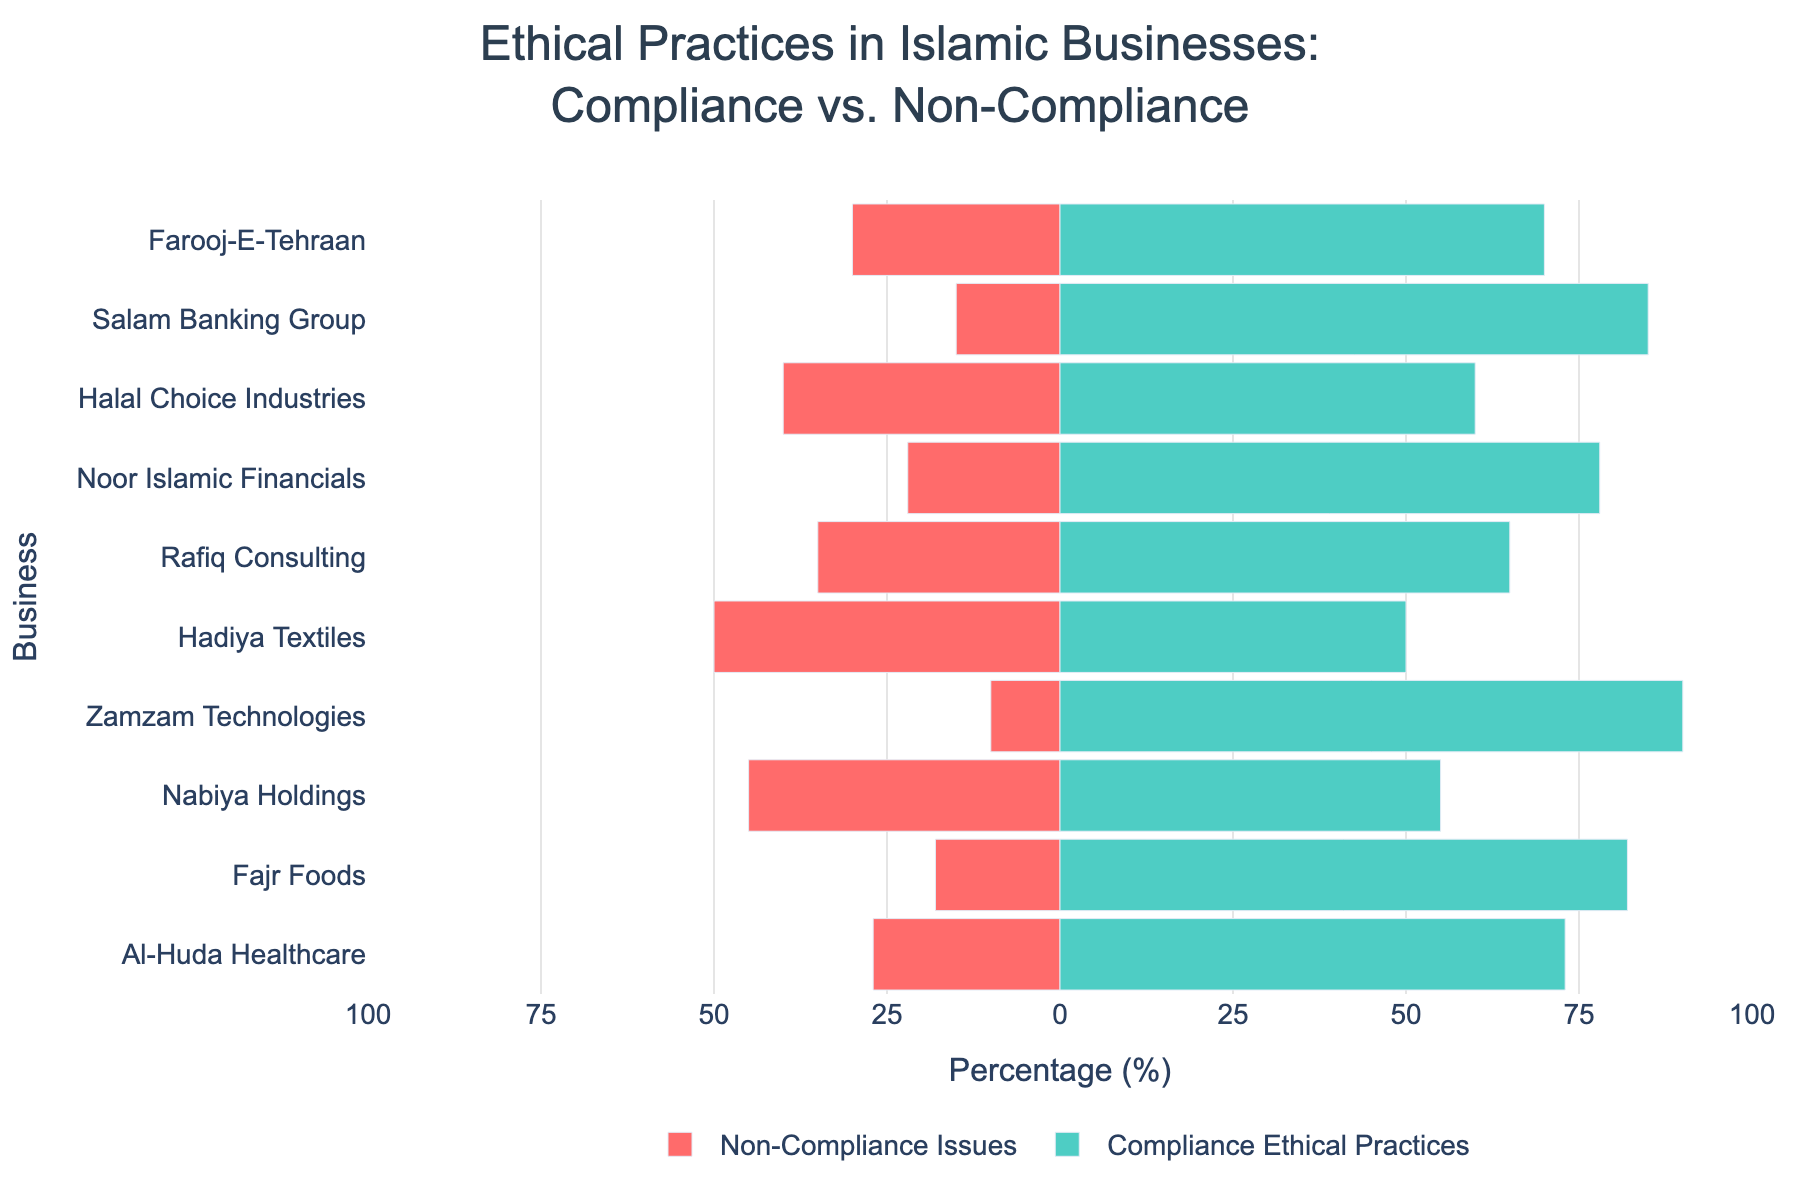Which business has the highest percentage of compliance with ethical practices? To find the business with the highest percentage of compliance, look for the bar with the longest green section. Zamzam Technologies has the highest compliance at 90%.
Answer: Zamzam Technologies Which business has the highest percentage of non-compliance issues? To find the business with the highest percentage of non-compliance issues, look for the bar with the longest red section. Halal Choice Industries has the highest non-compliance at 40%.
Answer: Halal Choice Industries Compare the compliance percentages of Salam Banking Group and Noor Islamic Financials. Which one has higher compliance? Look at the green bars for both Salam Banking Group and Noor Islamic Financials. Salam Banking Group has 85% compliance while Noor Islamic Financials has 78%. So, Salam Banking Group has higher compliance.
Answer: Salam Banking Group What is the combined percentage of compliance for Al-Huda Healthcare and Farooj-E-Tehraan? Al-Huda Healthcare has 73% compliance and Farooj-E-Tehraan has 70% compliance. Adding these together gives 73 + 70 = 143%.
Answer: 143% Among the businesses with more than 30% non-compliance issues, which one has the lowest percentage of non-compliance? First, identify businesses with more than 30% non-compliance: Farooj-E-Tehraan (30%), Halal Choice Industries (40%), Rafiq Consulting (35%), Hadiya Textiles (50%), and Nabiya Holdings (45%). Then, find the lowest percentage: Farooj-E-Tehraan with 30%.
Answer: Farooj-E-Tehraan Which businesses have an equal percentage of compliance and non-compliance? Identify the business where the green and red sections are equal lengths. Hadiya Textiles has 50% compliance and 50% non-compliance, making them equal.
Answer: Hadiya Textiles What is the average compliance percentage across all businesses? Sum the compliance percentages and divide by the number of businesses. (70 + 85 + 60 + 78 + 65 + 50 + 90 + 55 + 82 + 73) / 10 = 70.8%
Answer: 70.8% Which businesses have more than 75% compliance? Identify businesses with green bars extending past the 75% mark: Salam Banking Group (85%), Noor Islamic Financials (78%), Zamzam Technologies (90%), and Fajr Foods (82%).
Answer: Salam Banking Group, Noor Islamic Financials, Zamzam Technologies, Fajr Foods What is the difference in compliance percentages between Fajr Foods and Nabiya Holdings? Fajr Foods has 82% compliance and Nabiya Holdings has 55% compliance. The difference is 82 - 55 = 27%.
Answer: 27% Compare the non-compliance issues for Rafiq Consulting and Hadiya Textiles. Which one has fewer non-compliance issues? Rafiq Consulting has 35% non-compliance, whereas Hadiya Textiles has 50%. Therefore, Rafiq Consulting has fewer non-compliance issues.
Answer: Rafiq Consulting 